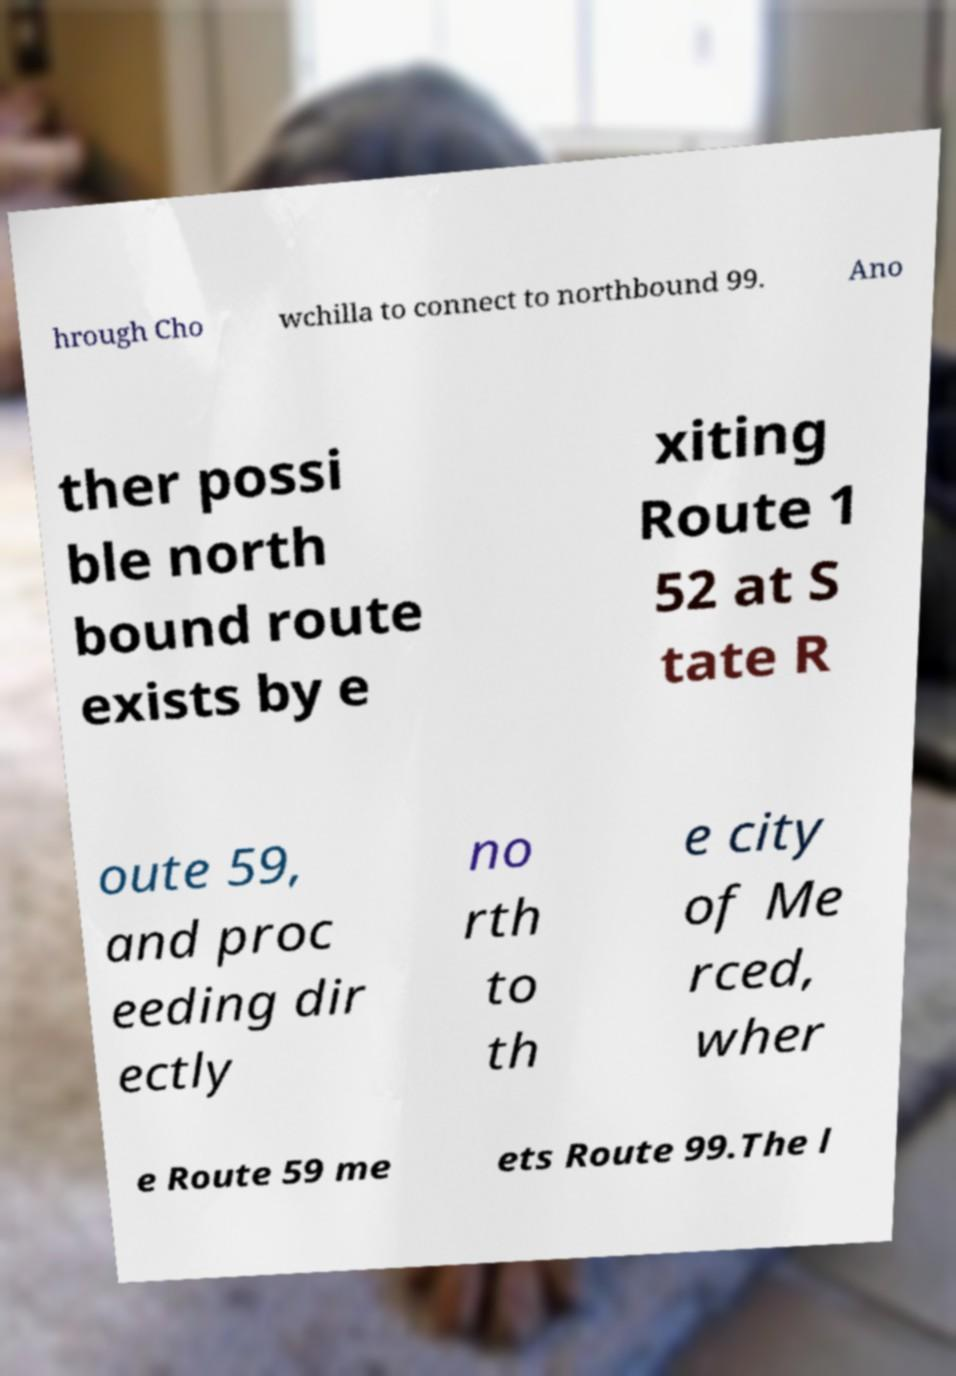For documentation purposes, I need the text within this image transcribed. Could you provide that? hrough Cho wchilla to connect to northbound 99. Ano ther possi ble north bound route exists by e xiting Route 1 52 at S tate R oute 59, and proc eeding dir ectly no rth to th e city of Me rced, wher e Route 59 me ets Route 99.The l 